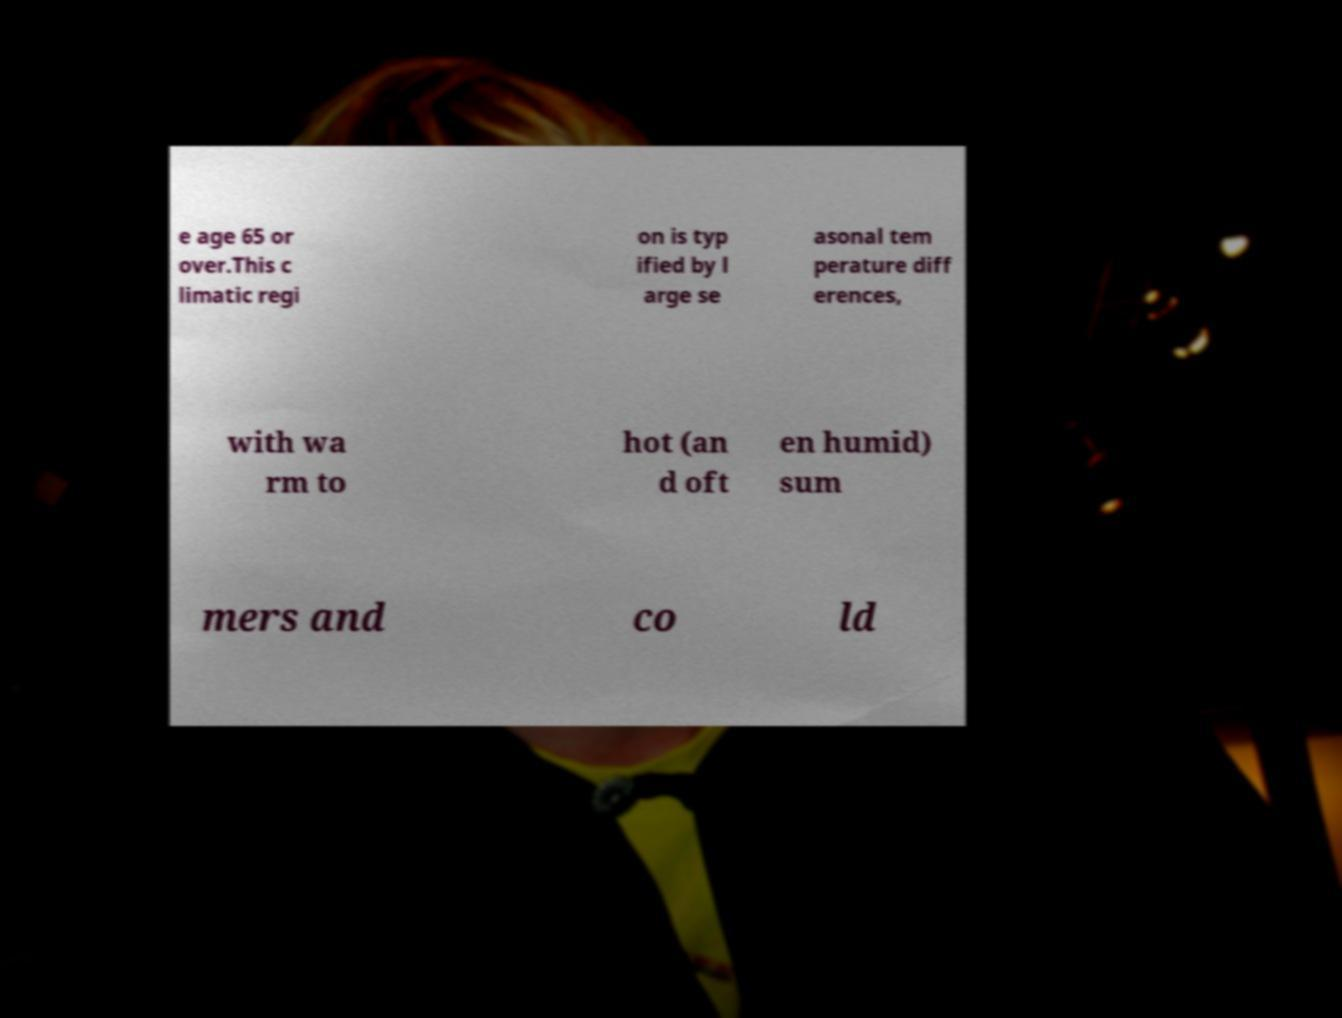What messages or text are displayed in this image? I need them in a readable, typed format. e age 65 or over.This c limatic regi on is typ ified by l arge se asonal tem perature diff erences, with wa rm to hot (an d oft en humid) sum mers and co ld 